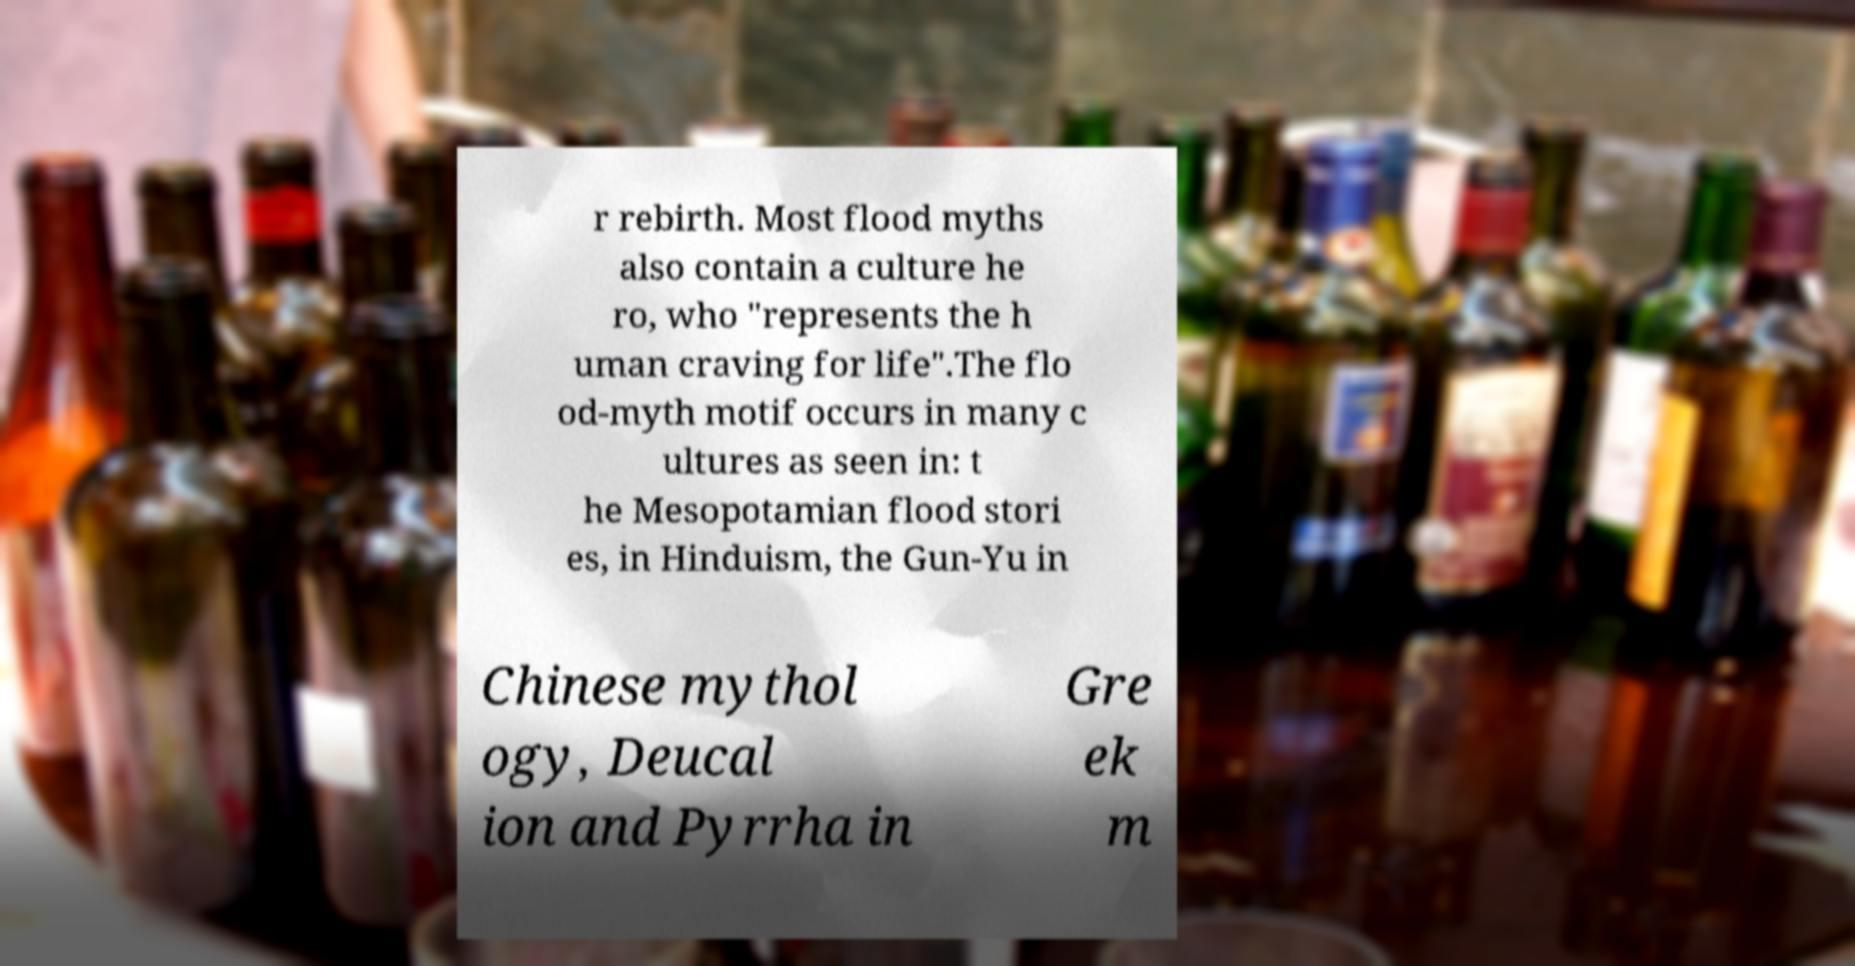Can you accurately transcribe the text from the provided image for me? r rebirth. Most flood myths also contain a culture he ro, who "represents the h uman craving for life".The flo od-myth motif occurs in many c ultures as seen in: t he Mesopotamian flood stori es, in Hinduism, the Gun-Yu in Chinese mythol ogy, Deucal ion and Pyrrha in Gre ek m 